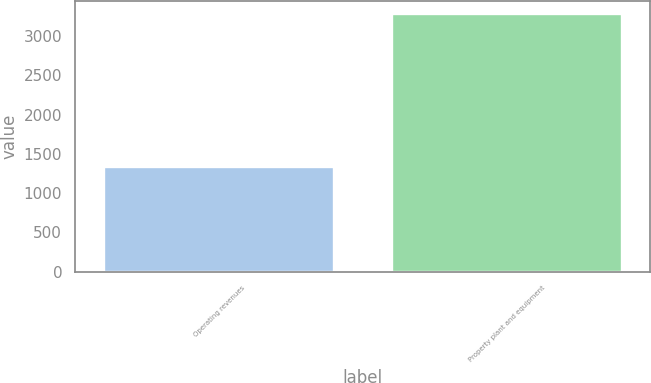<chart> <loc_0><loc_0><loc_500><loc_500><bar_chart><fcel>Operating revenues<fcel>Property plant and equipment<nl><fcel>1334<fcel>3288<nl></chart> 